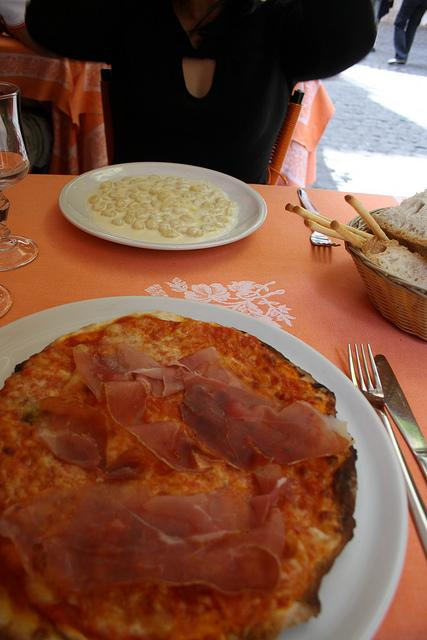What are the sticks seen here made from?

Choices:
A) bread
B) drumsticks
C) chicken
D) beef bread 